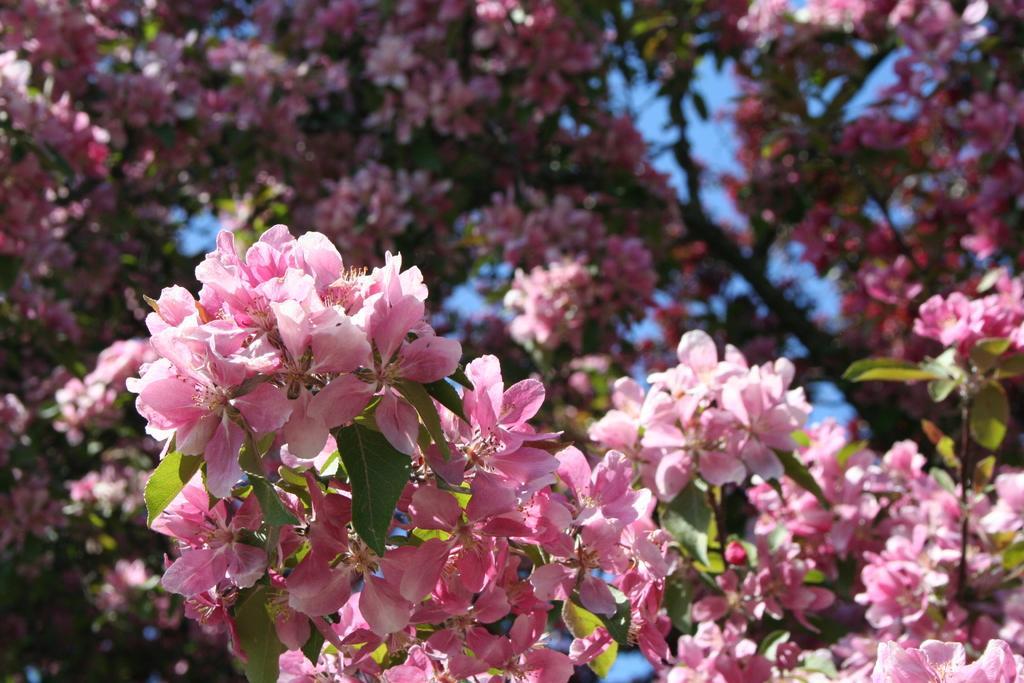Describe this image in one or two sentences. In this message I can see a tree along with the flowers and leaves. The flowers are in pink color. In the background, I can see the sky. 